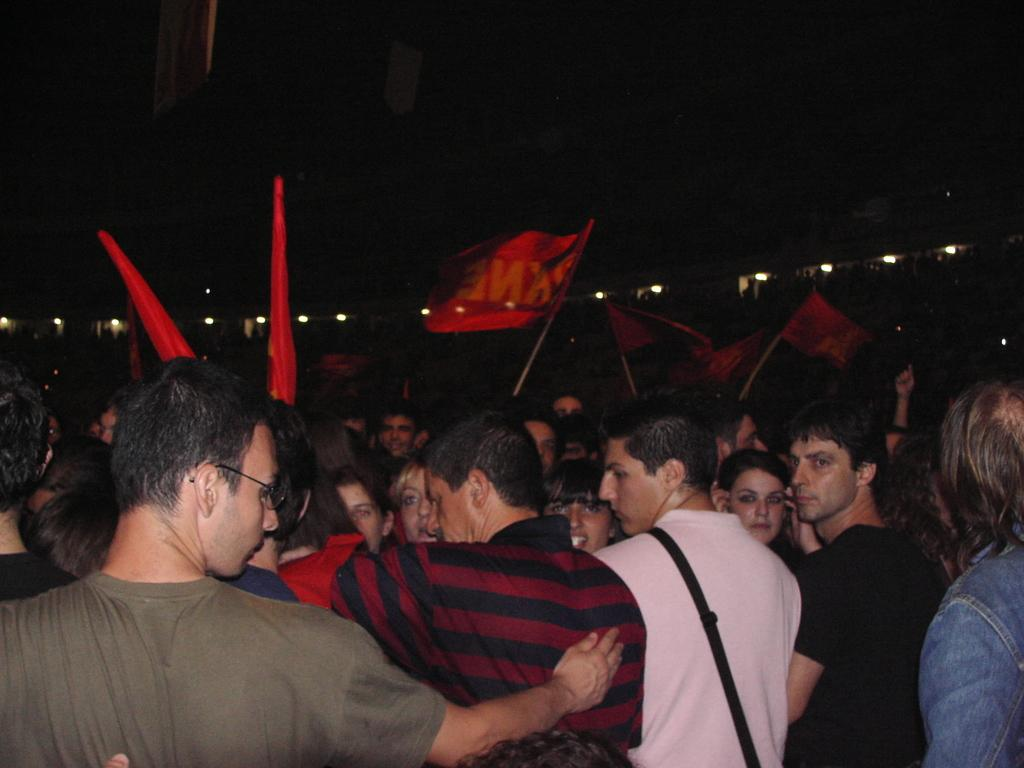What are the people in the image doing? The people are standing in the image, and they are protesting. What can be seen on the flags that the protesters are holding? The protesters are holding red flags. What is visible in the background of the image? There are lights visible in the background of the image. How many cushions can be seen on the window in the image? There are no cushions or windows present in the image. What type of copy machine is visible in the image? There is no copy machine present in the image. 